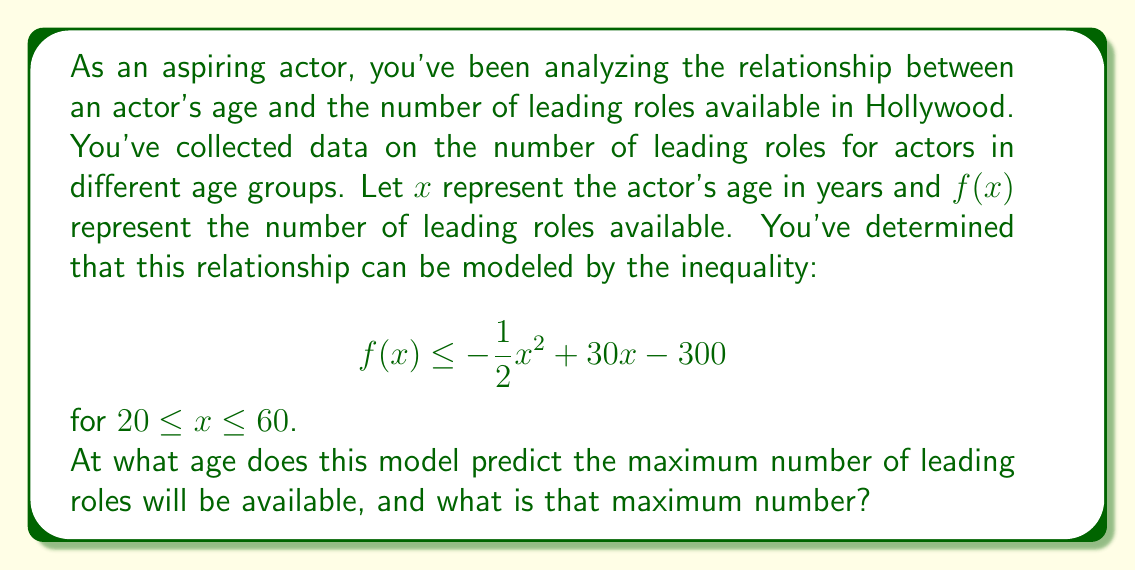What is the answer to this math problem? To solve this problem, we need to follow these steps:

1) The function $f(x) = -\frac{1}{2}x^2 + 30x - 300$ is a quadratic function, and its graph is a parabola that opens downward due to the negative coefficient of $x^2$.

2) The maximum point of a parabola occurs at the vertex. For a quadratic function in the form $f(x) = ax^2 + bx + c$, the x-coordinate of the vertex is given by $x = -\frac{b}{2a}$.

3) In our case, $a = -\frac{1}{2}$, $b = 30$, and $c = -300$. Let's calculate the x-coordinate of the vertex:

   $x = -\frac{b}{2a} = -\frac{30}{2(-\frac{1}{2})} = -\frac{30}{-1} = 30$

4) This means the maximum occurs when the actor's age is 30 years.

5) To find the maximum number of roles, we need to calculate $f(30)$:

   $f(30) = -\frac{1}{2}(30)^2 + 30(30) - 300$
          $= -\frac{1}{2}(900) + 900 - 300$
          $= -450 + 900 - 300$
          $= 150$

Therefore, the model predicts a maximum of 150 leading roles at age 30.
Answer: The model predicts the maximum number of leading roles will be available at age 30, with a maximum of 150 roles. 